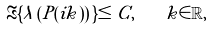Convert formula to latex. <formula><loc_0><loc_0><loc_500><loc_500>\Re \{ \lambda \left ( P ( i k ) \right ) \} \leq C , \quad k \in \mathbb { R } ,</formula> 